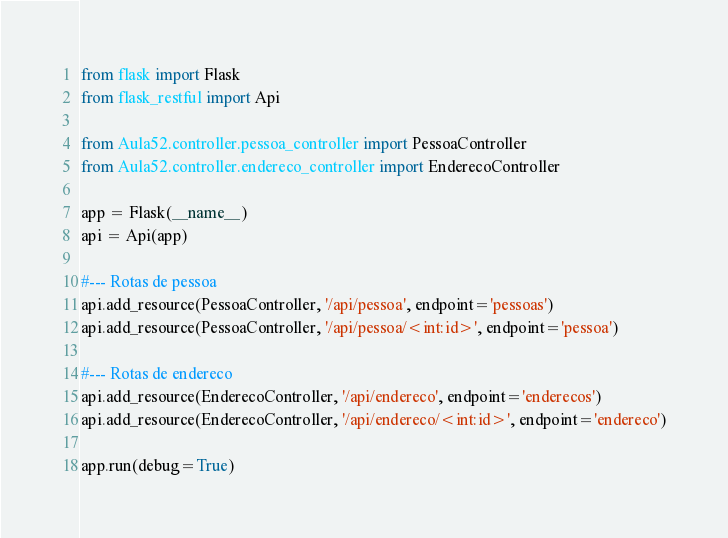<code> <loc_0><loc_0><loc_500><loc_500><_Python_>from flask import Flask
from flask_restful import Api

from Aula52.controller.pessoa_controller import PessoaController
from Aula52.controller.endereco_controller import EnderecoController

app = Flask(__name__)
api = Api(app)

#--- Rotas de pessoa
api.add_resource(PessoaController, '/api/pessoa', endpoint='pessoas')
api.add_resource(PessoaController, '/api/pessoa/<int:id>', endpoint='pessoa')

#--- Rotas de endereco
api.add_resource(EnderecoController, '/api/endereco', endpoint='enderecos')
api.add_resource(EnderecoController, '/api/endereco/<int:id>', endpoint='endereco')

app.run(debug=True)</code> 